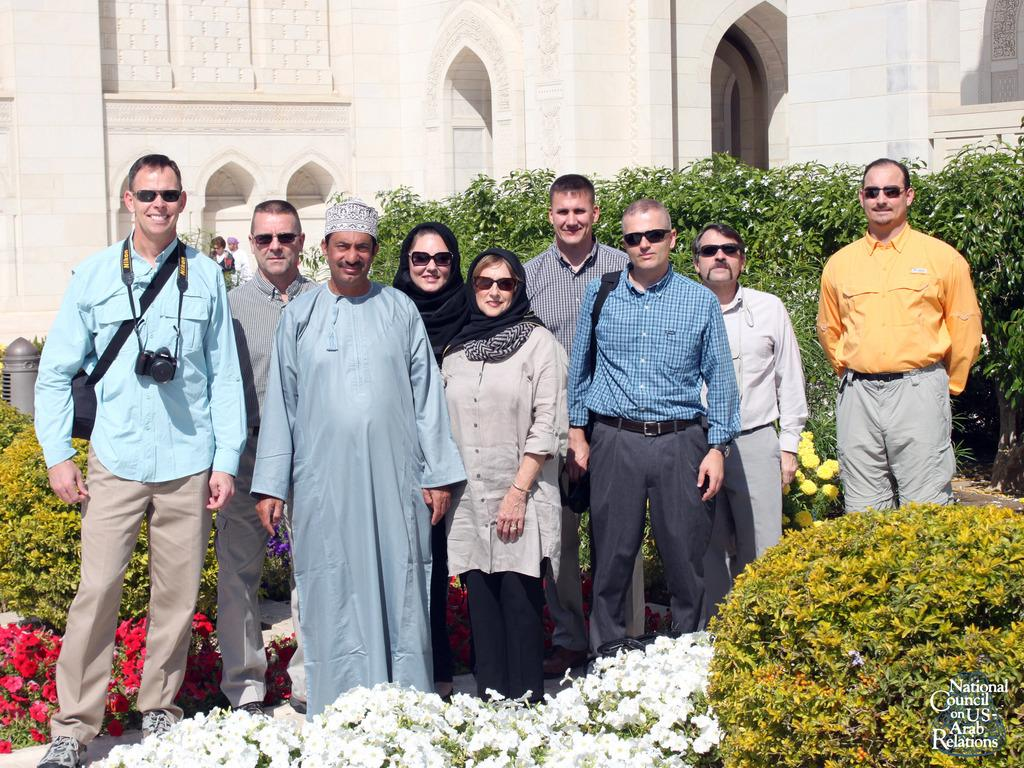What is happening in the image involving people? There is a group of people standing in the image. What type of vegetation is present in the image? There are plants with flowers in the image. What can be seen in the distance in the image? There is a building in the background of the image. Is there any indication of ownership or origin on the image? Yes, there is a watermark on the image. What type of nail is being used to hold the ball in the image? There is no nail or ball present in the image. 